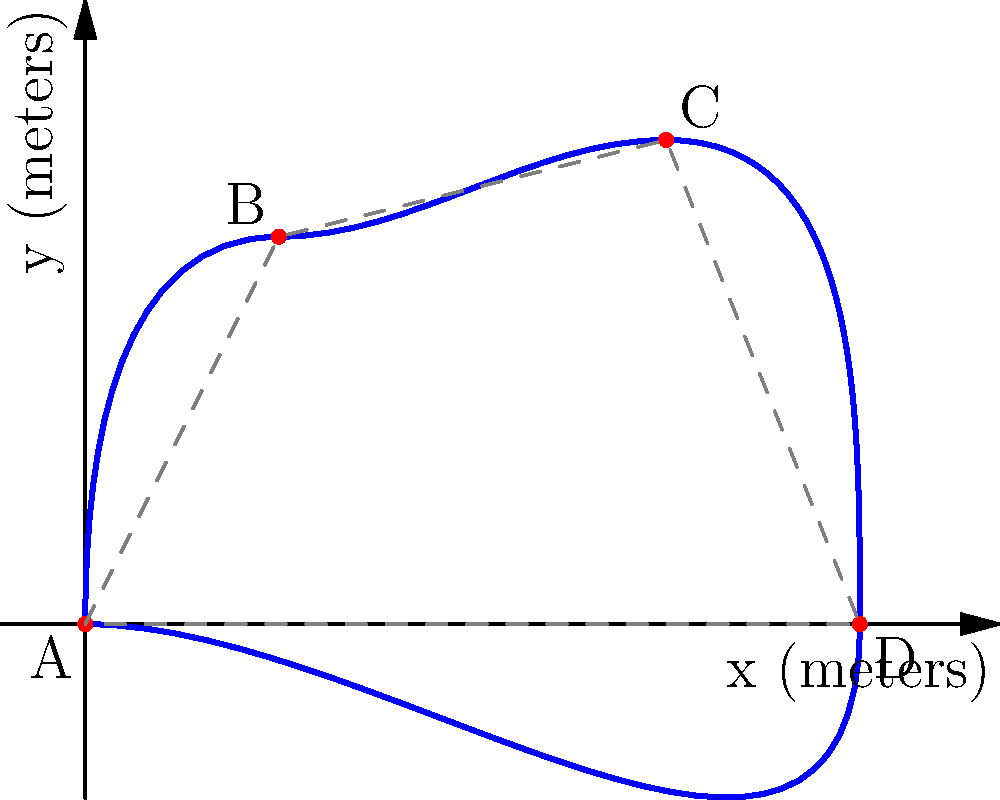As a sociologist studying urban design, you're analyzing the perimeter of an irregularly shaped public park. The park's boundary is represented by the blue curve in the diagram. To estimate the perimeter, you've identified four key points (A, B, C, and D) along the curve and connected them with straight lines (shown as dashed gray lines). If the straight-line distances between consecutive points are AB = 2.24m, BC = 2.06m, CD = 2.92m, and DA = 4m, estimate the actual perimeter of the park. Assume that each curved segment between two points is approximately 15% longer than its corresponding straight line segment. To estimate the perimeter of the irregularly shaped park, we'll follow these steps:

1) First, calculate the sum of the straight-line distances:
   $S = AB + BC + CD + DA = 2.24 + 2.06 + 2.92 + 4 = 11.22$ meters

2) Now, we need to account for the curvature. Each curved segment is approximately 15% longer than its straight-line counterpart. To calculate this, we multiply the straight-line sum by 1.15:

   $P_{estimated} = S \times 1.15 = 11.22 \times 1.15 = 12.903$ meters

3) Round to a reasonable number of significant figures, considering the precision of the original measurements:

   $P_{estimated} \approx 12.9$ meters

This method provides an estimate of the park's perimeter, accounting for the curved nature of its boundaries. It's important to note that this is an approximation, and the actual perimeter may vary slightly depending on the exact shape of the curves.
Answer: $12.9$ meters 